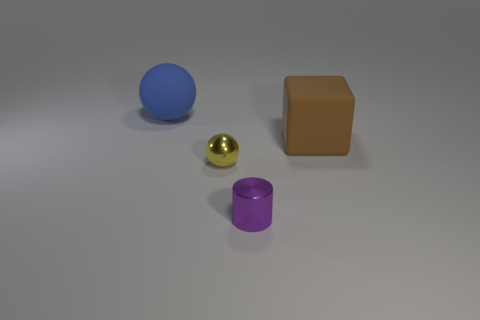Add 4 big yellow metallic blocks. How many objects exist? 8 Subtract all blocks. How many objects are left? 3 Add 2 large brown objects. How many large brown objects are left? 3 Add 2 big purple objects. How many big purple objects exist? 2 Subtract 0 brown spheres. How many objects are left? 4 Subtract all small yellow metal balls. Subtract all purple cylinders. How many objects are left? 2 